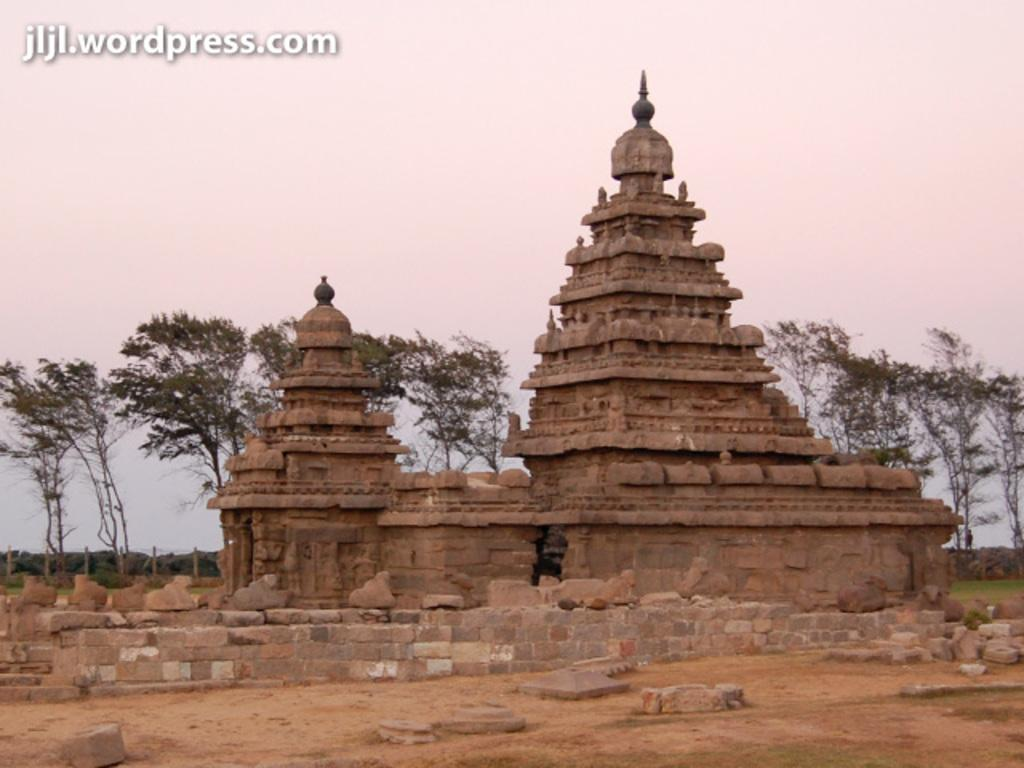What can be seen in the foreground of the image? In the foreground of the image, there is land, a stone wall, and a temple. What type of structure is present in the foreground? There is a temple in the foreground of the image. What can be seen in the background of the image? In the background of the image, there are trees and the sky is visible. What is the primary feature of the temple in the image? The temple's primary feature is its presence in the foreground of the image. What type of company is depicted in the image? There is no company depicted in the image; it features a temple, land, and a stone wall in the foreground, with trees and the sky in the background. How many fingers can be seen interacting with the temple in the image? There are no fingers visible in the image; it only features a temple, land, a stone wall, trees, and the sky. 